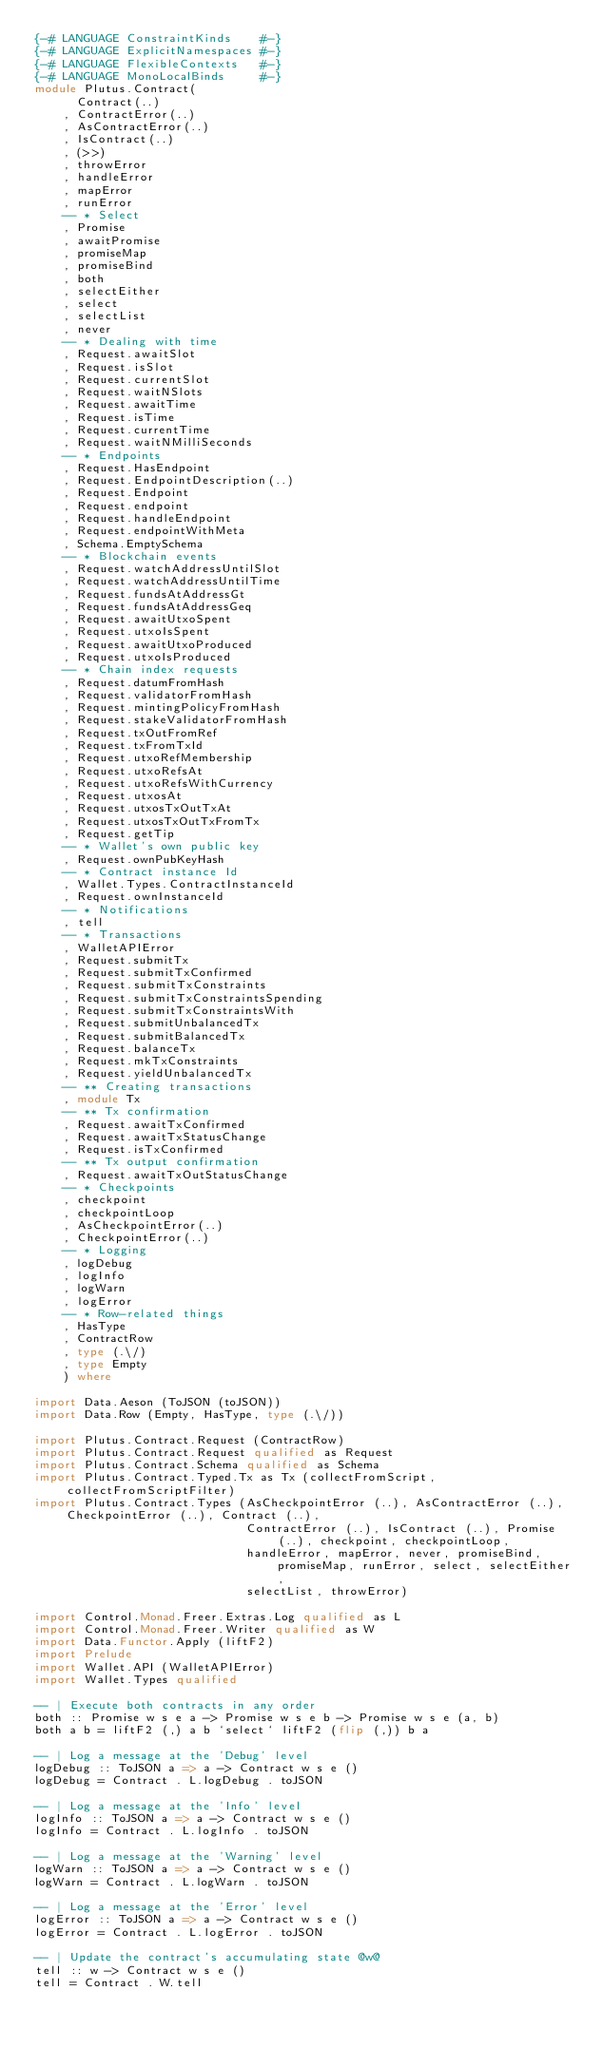Convert code to text. <code><loc_0><loc_0><loc_500><loc_500><_Haskell_>{-# LANGUAGE ConstraintKinds    #-}
{-# LANGUAGE ExplicitNamespaces #-}
{-# LANGUAGE FlexibleContexts   #-}
{-# LANGUAGE MonoLocalBinds     #-}
module Plutus.Contract(
      Contract(..)
    , ContractError(..)
    , AsContractError(..)
    , IsContract(..)
    , (>>)
    , throwError
    , handleError
    , mapError
    , runError
    -- * Select
    , Promise
    , awaitPromise
    , promiseMap
    , promiseBind
    , both
    , selectEither
    , select
    , selectList
    , never
    -- * Dealing with time
    , Request.awaitSlot
    , Request.isSlot
    , Request.currentSlot
    , Request.waitNSlots
    , Request.awaitTime
    , Request.isTime
    , Request.currentTime
    , Request.waitNMilliSeconds
    -- * Endpoints
    , Request.HasEndpoint
    , Request.EndpointDescription(..)
    , Request.Endpoint
    , Request.endpoint
    , Request.handleEndpoint
    , Request.endpointWithMeta
    , Schema.EmptySchema
    -- * Blockchain events
    , Request.watchAddressUntilSlot
    , Request.watchAddressUntilTime
    , Request.fundsAtAddressGt
    , Request.fundsAtAddressGeq
    , Request.awaitUtxoSpent
    , Request.utxoIsSpent
    , Request.awaitUtxoProduced
    , Request.utxoIsProduced
    -- * Chain index requests
    , Request.datumFromHash
    , Request.validatorFromHash
    , Request.mintingPolicyFromHash
    , Request.stakeValidatorFromHash
    , Request.txOutFromRef
    , Request.txFromTxId
    , Request.utxoRefMembership
    , Request.utxoRefsAt
    , Request.utxoRefsWithCurrency
    , Request.utxosAt
    , Request.utxosTxOutTxAt
    , Request.utxosTxOutTxFromTx
    , Request.getTip
    -- * Wallet's own public key
    , Request.ownPubKeyHash
    -- * Contract instance Id
    , Wallet.Types.ContractInstanceId
    , Request.ownInstanceId
    -- * Notifications
    , tell
    -- * Transactions
    , WalletAPIError
    , Request.submitTx
    , Request.submitTxConfirmed
    , Request.submitTxConstraints
    , Request.submitTxConstraintsSpending
    , Request.submitTxConstraintsWith
    , Request.submitUnbalancedTx
    , Request.submitBalancedTx
    , Request.balanceTx
    , Request.mkTxConstraints
    , Request.yieldUnbalancedTx
    -- ** Creating transactions
    , module Tx
    -- ** Tx confirmation
    , Request.awaitTxConfirmed
    , Request.awaitTxStatusChange
    , Request.isTxConfirmed
    -- ** Tx output confirmation
    , Request.awaitTxOutStatusChange
    -- * Checkpoints
    , checkpoint
    , checkpointLoop
    , AsCheckpointError(..)
    , CheckpointError(..)
    -- * Logging
    , logDebug
    , logInfo
    , logWarn
    , logError
    -- * Row-related things
    , HasType
    , ContractRow
    , type (.\/)
    , type Empty
    ) where

import Data.Aeson (ToJSON (toJSON))
import Data.Row (Empty, HasType, type (.\/))

import Plutus.Contract.Request (ContractRow)
import Plutus.Contract.Request qualified as Request
import Plutus.Contract.Schema qualified as Schema
import Plutus.Contract.Typed.Tx as Tx (collectFromScript, collectFromScriptFilter)
import Plutus.Contract.Types (AsCheckpointError (..), AsContractError (..), CheckpointError (..), Contract (..),
                              ContractError (..), IsContract (..), Promise (..), checkpoint, checkpointLoop,
                              handleError, mapError, never, promiseBind, promiseMap, runError, select, selectEither,
                              selectList, throwError)

import Control.Monad.Freer.Extras.Log qualified as L
import Control.Monad.Freer.Writer qualified as W
import Data.Functor.Apply (liftF2)
import Prelude
import Wallet.API (WalletAPIError)
import Wallet.Types qualified

-- | Execute both contracts in any order
both :: Promise w s e a -> Promise w s e b -> Promise w s e (a, b)
both a b = liftF2 (,) a b `select` liftF2 (flip (,)) b a

-- | Log a message at the 'Debug' level
logDebug :: ToJSON a => a -> Contract w s e ()
logDebug = Contract . L.logDebug . toJSON

-- | Log a message at the 'Info' level
logInfo :: ToJSON a => a -> Contract w s e ()
logInfo = Contract . L.logInfo . toJSON

-- | Log a message at the 'Warning' level
logWarn :: ToJSON a => a -> Contract w s e ()
logWarn = Contract . L.logWarn . toJSON

-- | Log a message at the 'Error' level
logError :: ToJSON a => a -> Contract w s e ()
logError = Contract . L.logError . toJSON

-- | Update the contract's accumulating state @w@
tell :: w -> Contract w s e ()
tell = Contract . W.tell
</code> 